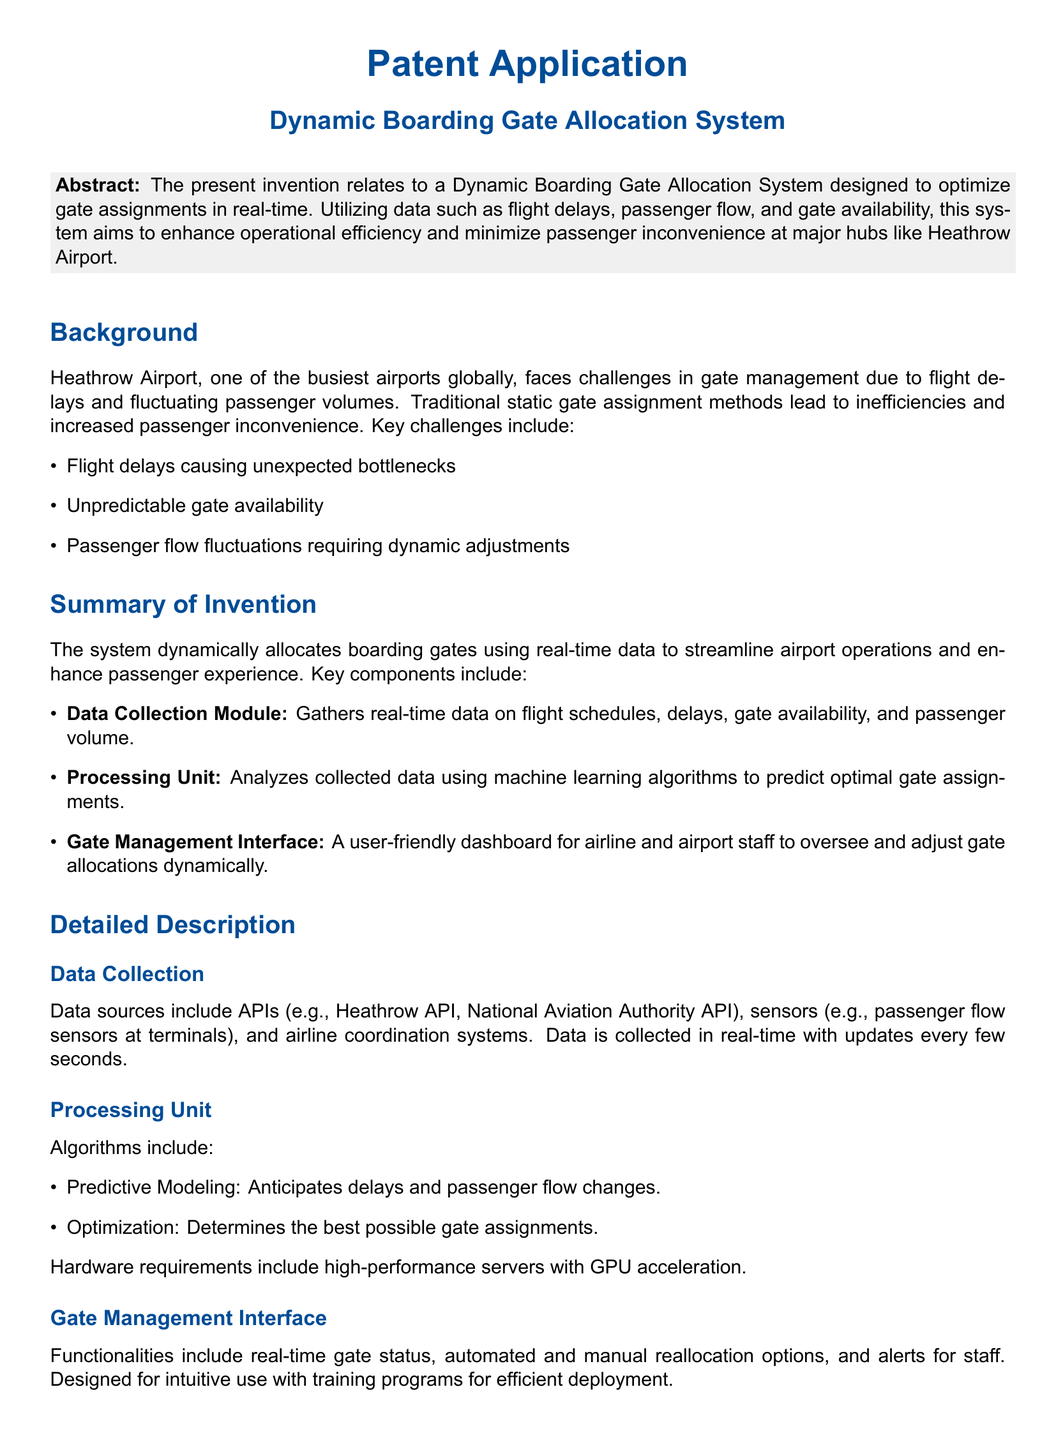What is the title of the patent application? The title provided in the document clearly states the focus of the invention.
Answer: Dynamic Boarding Gate Allocation System What type of data does the system utilize? The types of data mentioned are crucial for the functioning of the system.
Answer: Real-time data Which airport is specifically mentioned in the document? This information identifies the primary location targeted by the system.
Answer: Heathrow Airport What is one key challenge faced by Heathrow Airport? The document lists specific challenges that traditional gate management methods encounter.
Answer: Flight delays What is a function of the Data Collection Module? Understanding this gives insight into what part of the system collects essential information.
Answer: Gathers real-time data What algorithms are included in the Processing Unit? The algorithms employed are important for how the system processes information.
Answer: Predictive Modeling and Optimization How often is data collected in real-time? This detail indicates the responsiveness of the system to changing conditions.
Answer: Every few seconds What does the Gate Management Interface provide? Recognizing this feature reveals how users interact with the system.
Answer: Real-time gate status What does the conclusion of the document emphasize? The emphasis in the conclusion summarizes the overall benefit of the invention.
Answer: Improves passenger experience and operational efficiency 